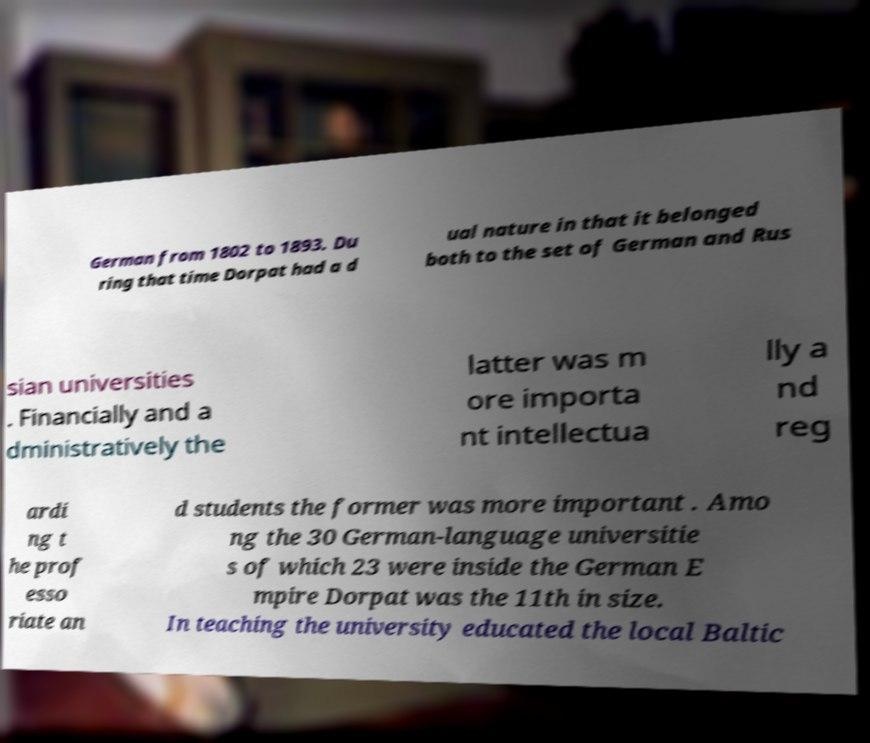Can you accurately transcribe the text from the provided image for me? German from 1802 to 1893. Du ring that time Dorpat had a d ual nature in that it belonged both to the set of German and Rus sian universities . Financially and a dministratively the latter was m ore importa nt intellectua lly a nd reg ardi ng t he prof esso riate an d students the former was more important . Amo ng the 30 German-language universitie s of which 23 were inside the German E mpire Dorpat was the 11th in size. In teaching the university educated the local Baltic 